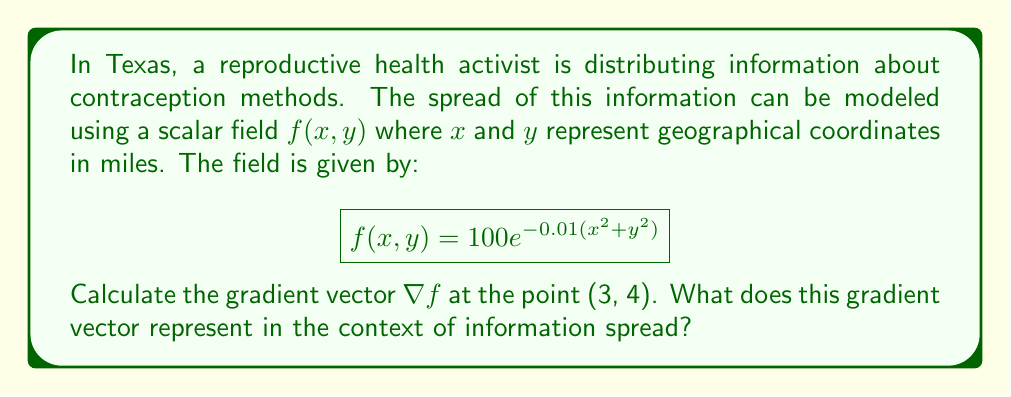Solve this math problem. To solve this problem, we'll follow these steps:

1) The gradient of a scalar field $f(x,y)$ is defined as:

   $$\nabla f = \left(\frac{\partial f}{\partial x}, \frac{\partial f}{\partial y}\right)$$

2) We need to calculate the partial derivatives:

   $\frac{\partial f}{\partial x} = 100 \cdot e^{-0.01(x^2+y^2)} \cdot (-0.02x)$
   $\frac{\partial f}{\partial y} = 100 \cdot e^{-0.01(x^2+y^2)} \cdot (-0.02y)$

3) Now, we evaluate these at the point (3, 4):

   $\frac{\partial f}{\partial x}|_{(3,4)} = 100 \cdot e^{-0.01(3^2+4^2)} \cdot (-0.02 \cdot 3)$
   $\frac{\partial f}{\partial y}|_{(3,4)} = 100 \cdot e^{-0.01(3^2+4^2)} \cdot (-0.02 \cdot 4)$

4) Simplify:
   
   $\frac{\partial f}{\partial x}|_{(3,4)} = 100 \cdot e^{-0.25} \cdot (-0.06) = -4.64$
   $\frac{\partial f}{\partial y}|_{(3,4)} = 100 \cdot e^{-0.25} \cdot (-0.08) = -6.19$

5) Therefore, the gradient vector at (3, 4) is:

   $$\nabla f|_{(3,4)} = (-4.64, -6.19)$$

This gradient vector represents the direction of steepest decrease in the spread of information at the point (3, 4). The negative values indicate that the information spread is decreasing in both the x and y directions, with a slightly steeper decrease in the y direction. The magnitude of this vector (about 7.73) represents the rate of this decrease.

In the context of information spread, this suggests that at 3 miles east and 4 miles north of the origin, the dissemination of contraception information is declining most rapidly in a south-southwesterly direction. The activist might use this information to identify areas where additional outreach efforts are needed to maintain or improve information spread.
Answer: $\nabla f|_{(3,4)} = (-4.64, -6.19)$ 